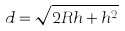Convert formula to latex. <formula><loc_0><loc_0><loc_500><loc_500>d = \sqrt { 2 R h + h ^ { 2 } }</formula> 